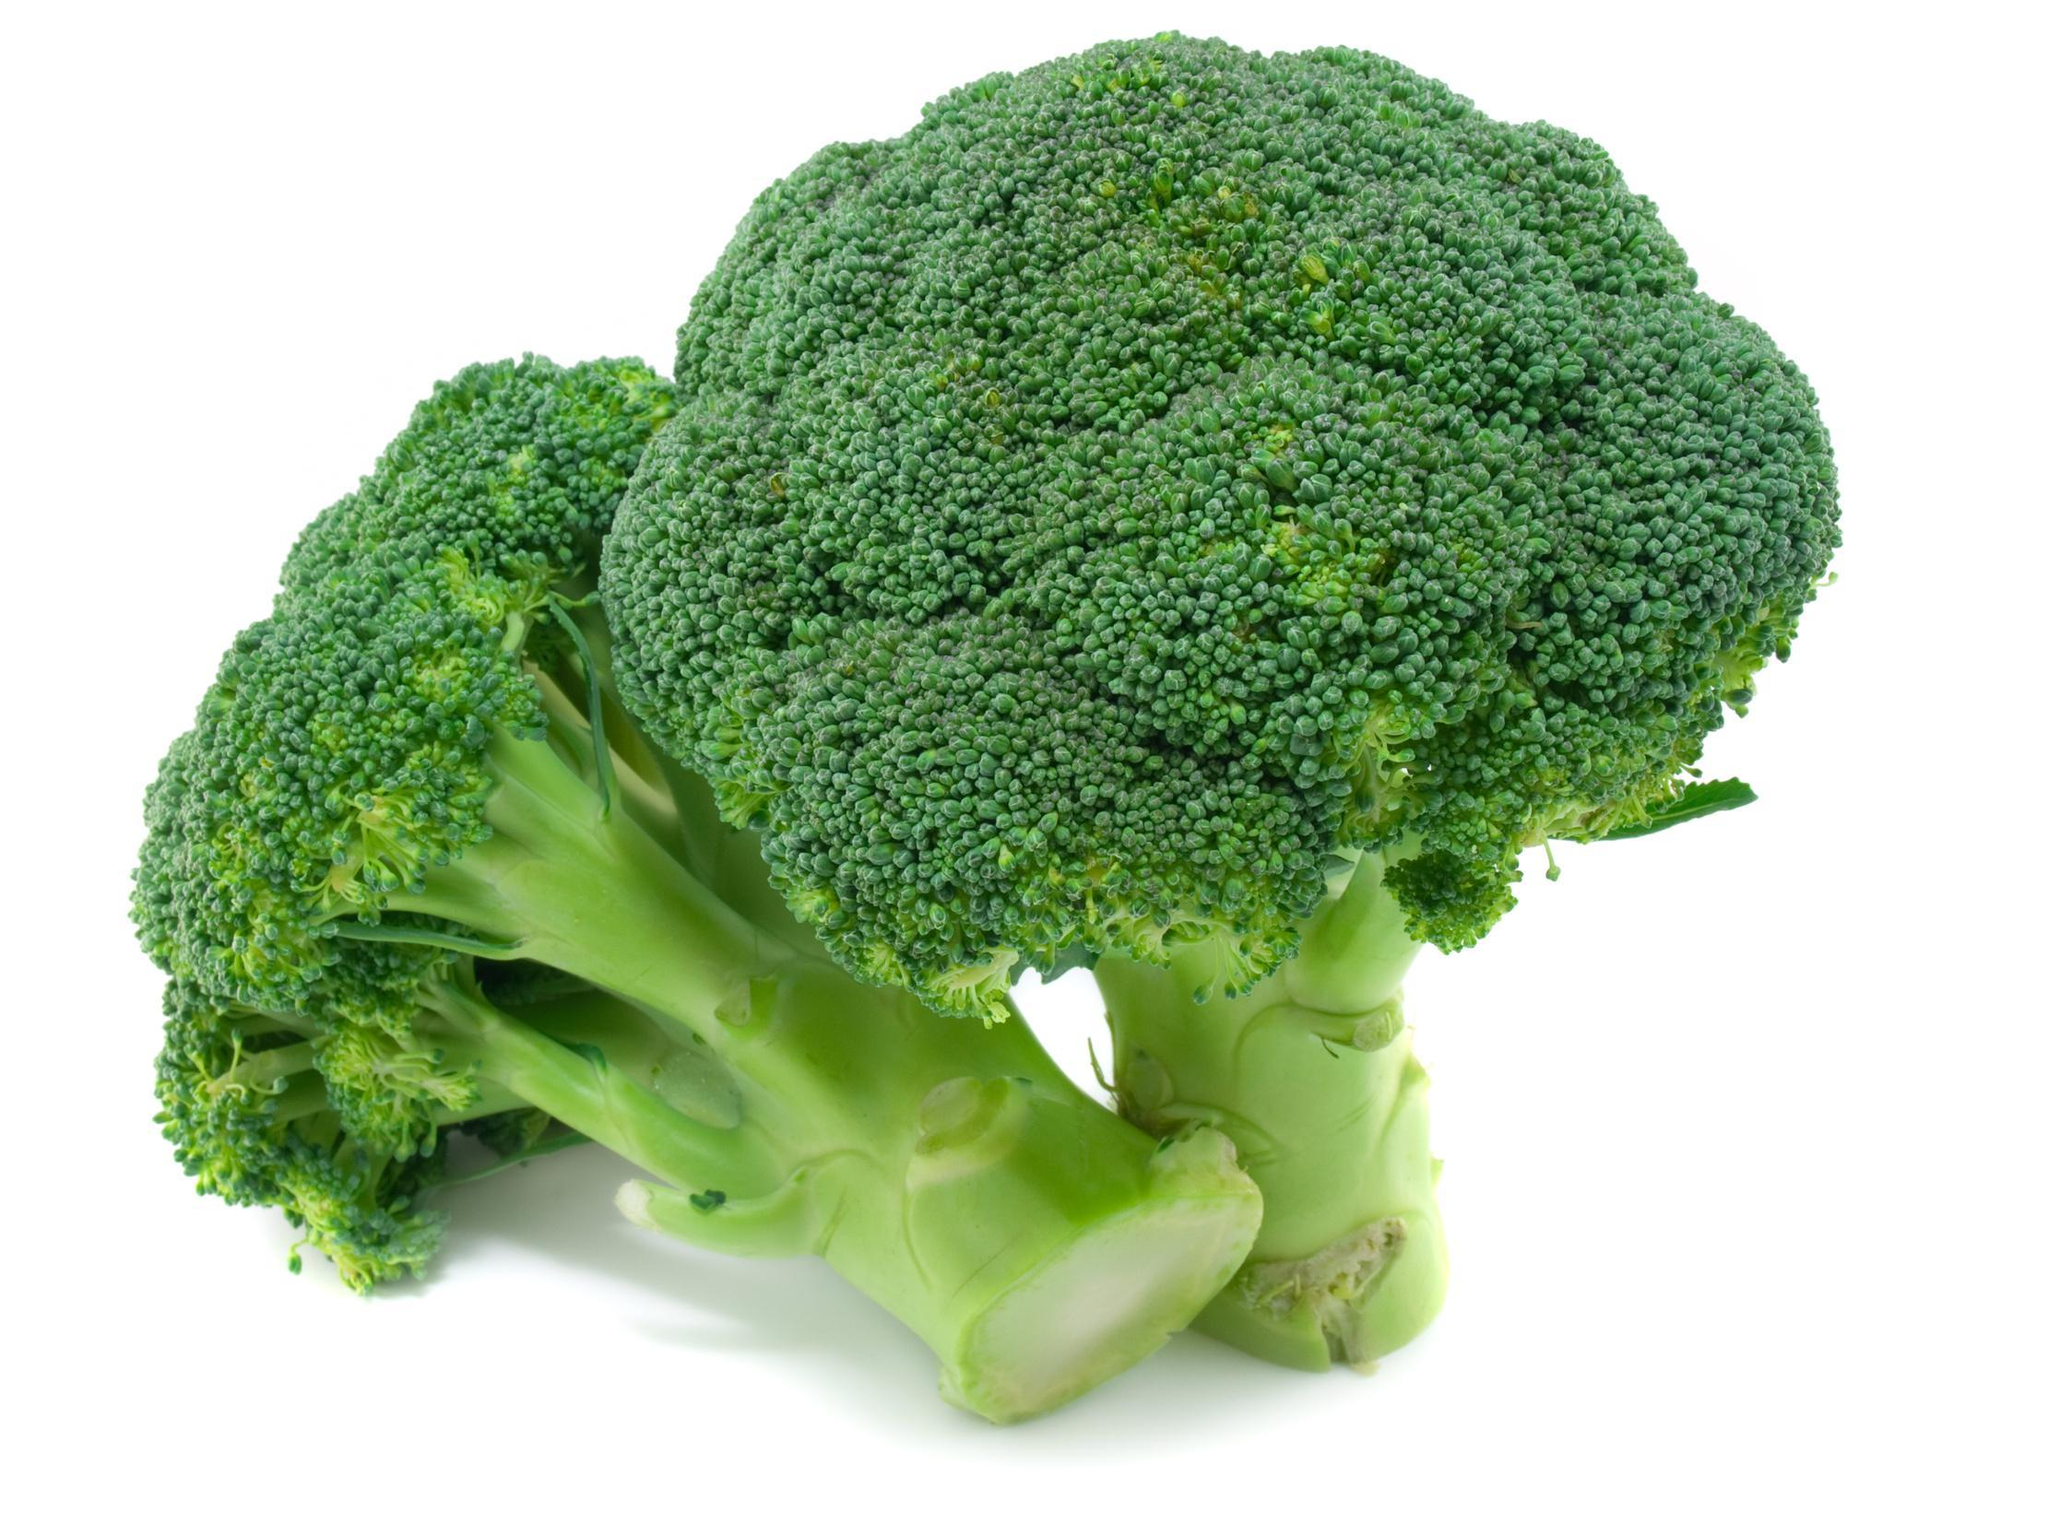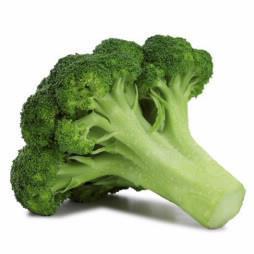The first image is the image on the left, the second image is the image on the right. For the images shown, is this caption "The broccoli on the right is a brighter green than on the left." true? Answer yes or no. No. The first image is the image on the left, the second image is the image on the right. Examine the images to the left and right. Is the description "No image contains more than five cut pieces of broccoli." accurate? Answer yes or no. Yes. 